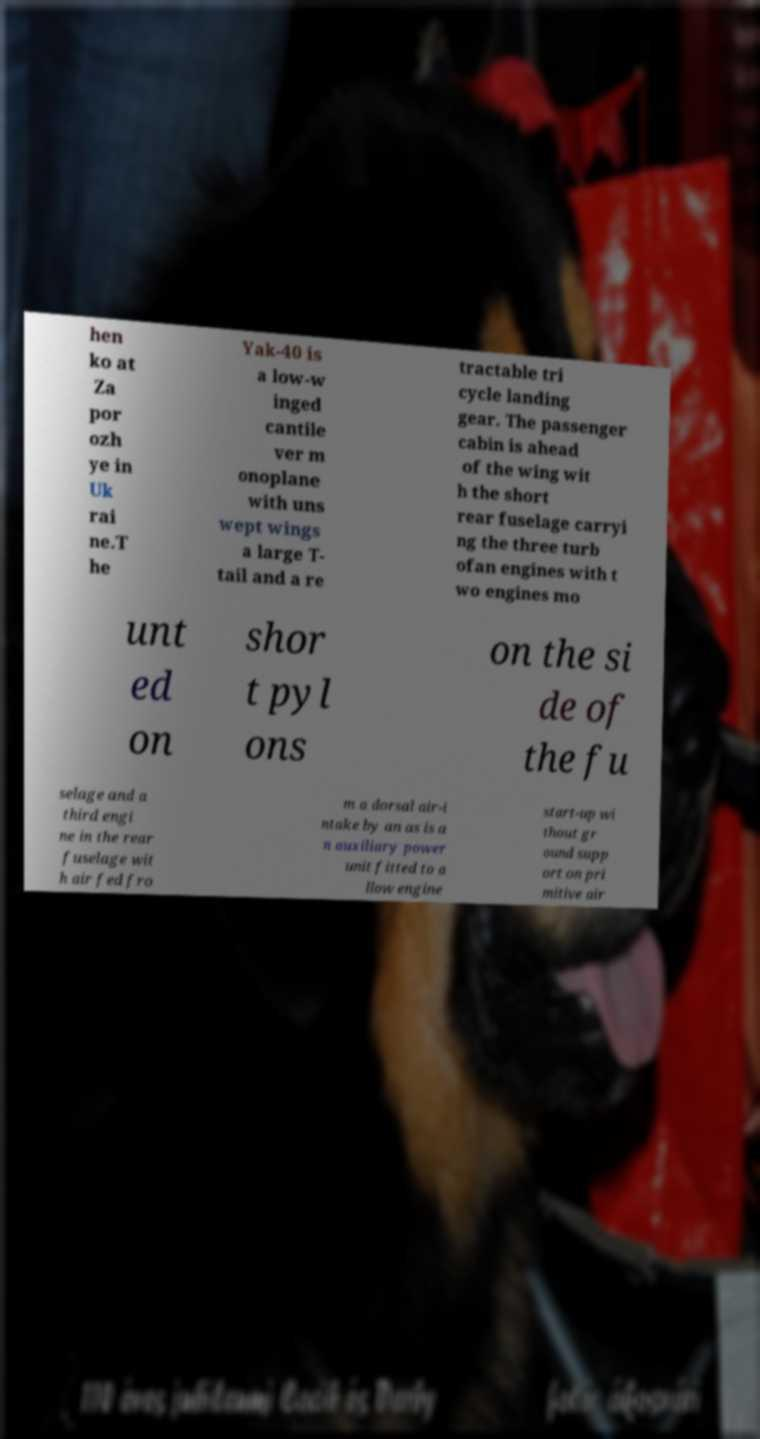Please identify and transcribe the text found in this image. hen ko at Za por ozh ye in Uk rai ne.T he Yak-40 is a low-w inged cantile ver m onoplane with uns wept wings a large T- tail and a re tractable tri cycle landing gear. The passenger cabin is ahead of the wing wit h the short rear fuselage carryi ng the three turb ofan engines with t wo engines mo unt ed on shor t pyl ons on the si de of the fu selage and a third engi ne in the rear fuselage wit h air fed fro m a dorsal air-i ntake by an as is a n auxiliary power unit fitted to a llow engine start-up wi thout gr ound supp ort on pri mitive air 